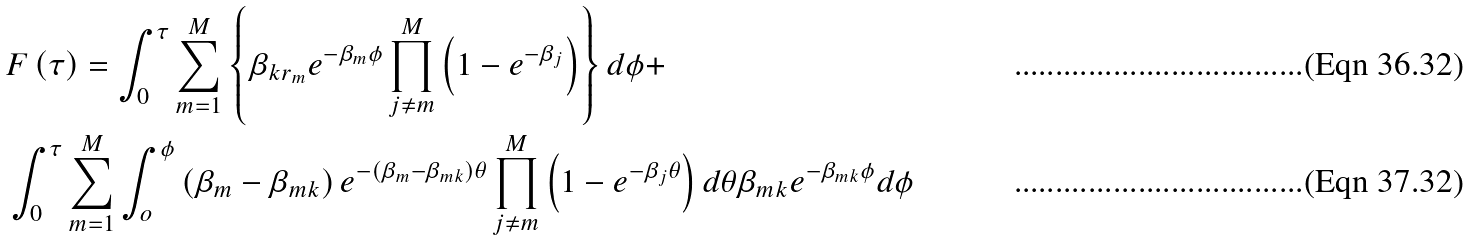<formula> <loc_0><loc_0><loc_500><loc_500>& F \left ( \tau \right ) = \int _ { 0 } ^ { \tau } \sum _ { m = 1 } ^ { M } \left \{ \beta _ { k r _ { m } } e ^ { - \beta _ { m } \phi } \prod _ { j \neq m } ^ { M } \left ( 1 - e ^ { - \beta _ { j } } \right ) \right \} d \phi + \\ & \int _ { 0 } ^ { \tau } \sum _ { m = 1 } ^ { M } \int _ { o } ^ { \phi } \left ( \beta _ { m } - \beta _ { m k } \right ) e ^ { - \left ( \beta _ { m } - \beta _ { m k } \right ) \theta } \prod _ { j \neq m } ^ { M } \left ( 1 - e ^ { - \beta _ { j } \theta } \right ) d \theta \beta _ { m k } e ^ { - \beta _ { m k } \phi } d \phi</formula> 